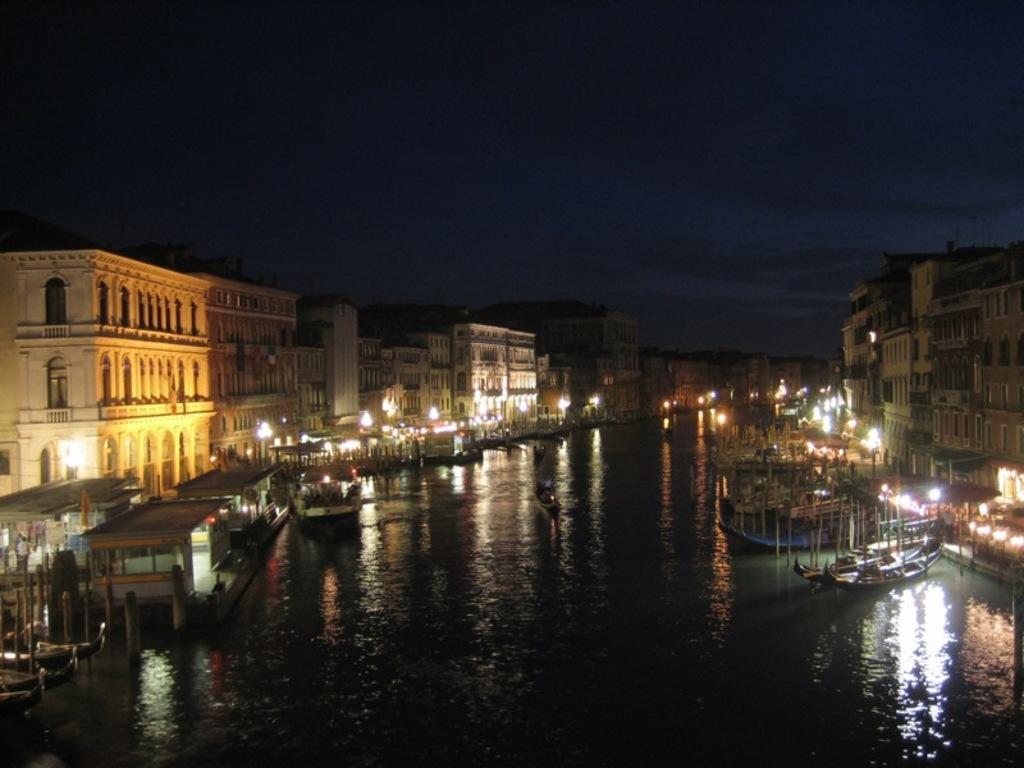How would you summarize this image in a sentence or two? In the center of the image we can see a canal and there are boats on the canal. In the background there are buildings, lights and sky. 